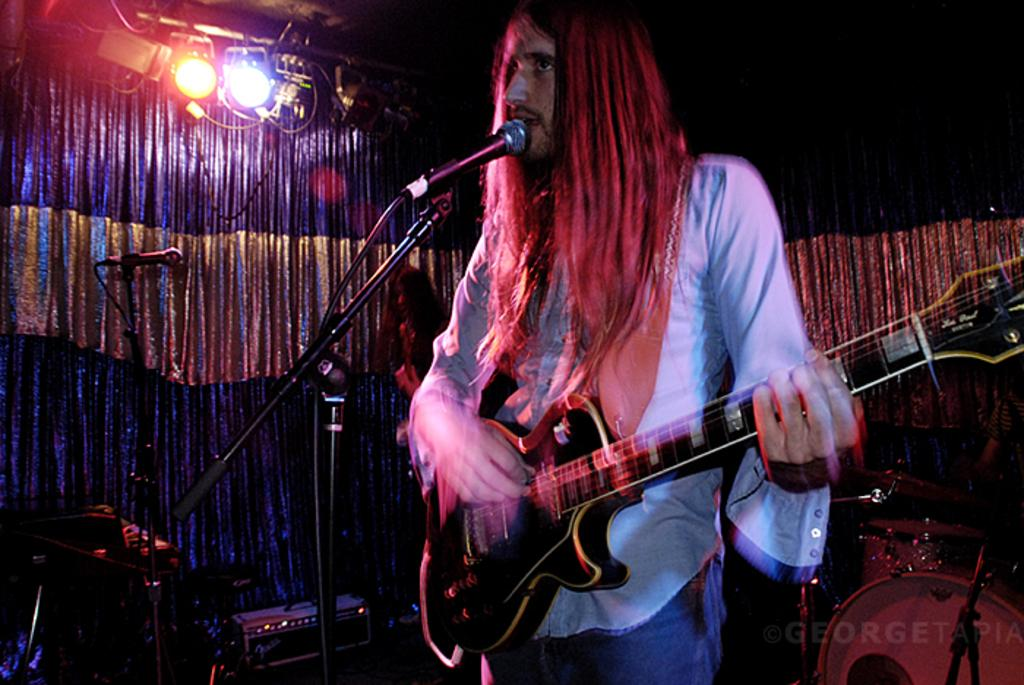What is the man in the image doing? The man is standing and holding a guitar. What object is in front of the man? There is a microphone in front of the man. What can be seen in the background of the image? There is a drum set, another microphone, and lights visible in the background. What type of food is the man eating in the image? There is no food present in the image; the man is holding a guitar and standing near a microphone and drum set. 